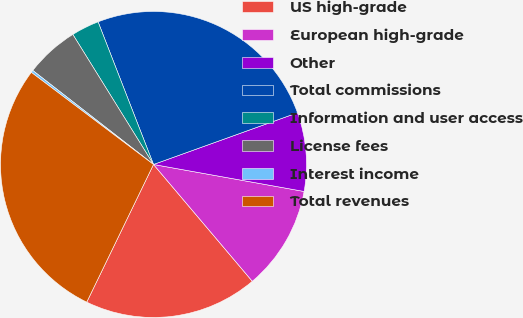<chart> <loc_0><loc_0><loc_500><loc_500><pie_chart><fcel>US high-grade<fcel>European high-grade<fcel>Other<fcel>Total commissions<fcel>Information and user access<fcel>License fees<fcel>Interest income<fcel>Total revenues<nl><fcel>18.36%<fcel>11.0%<fcel>8.31%<fcel>25.41%<fcel>2.94%<fcel>5.63%<fcel>0.25%<fcel>28.09%<nl></chart> 